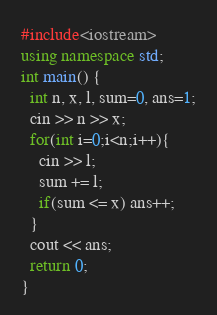Convert code to text. <code><loc_0><loc_0><loc_500><loc_500><_C++_>#include<iostream>
using namespace std;
int main() {
  int n, x, l, sum=0, ans=1;
  cin >> n >> x;
  for(int i=0;i<n;i++){
    cin >> l;
    sum += l;
    if(sum <= x) ans++;
  }
  cout << ans;
  return 0;
}</code> 